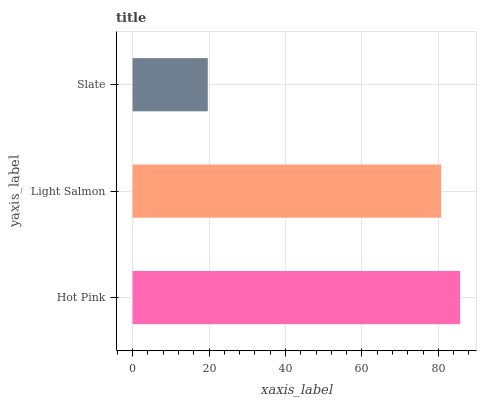Is Slate the minimum?
Answer yes or no. Yes. Is Hot Pink the maximum?
Answer yes or no. Yes. Is Light Salmon the minimum?
Answer yes or no. No. Is Light Salmon the maximum?
Answer yes or no. No. Is Hot Pink greater than Light Salmon?
Answer yes or no. Yes. Is Light Salmon less than Hot Pink?
Answer yes or no. Yes. Is Light Salmon greater than Hot Pink?
Answer yes or no. No. Is Hot Pink less than Light Salmon?
Answer yes or no. No. Is Light Salmon the high median?
Answer yes or no. Yes. Is Light Salmon the low median?
Answer yes or no. Yes. Is Hot Pink the high median?
Answer yes or no. No. Is Hot Pink the low median?
Answer yes or no. No. 